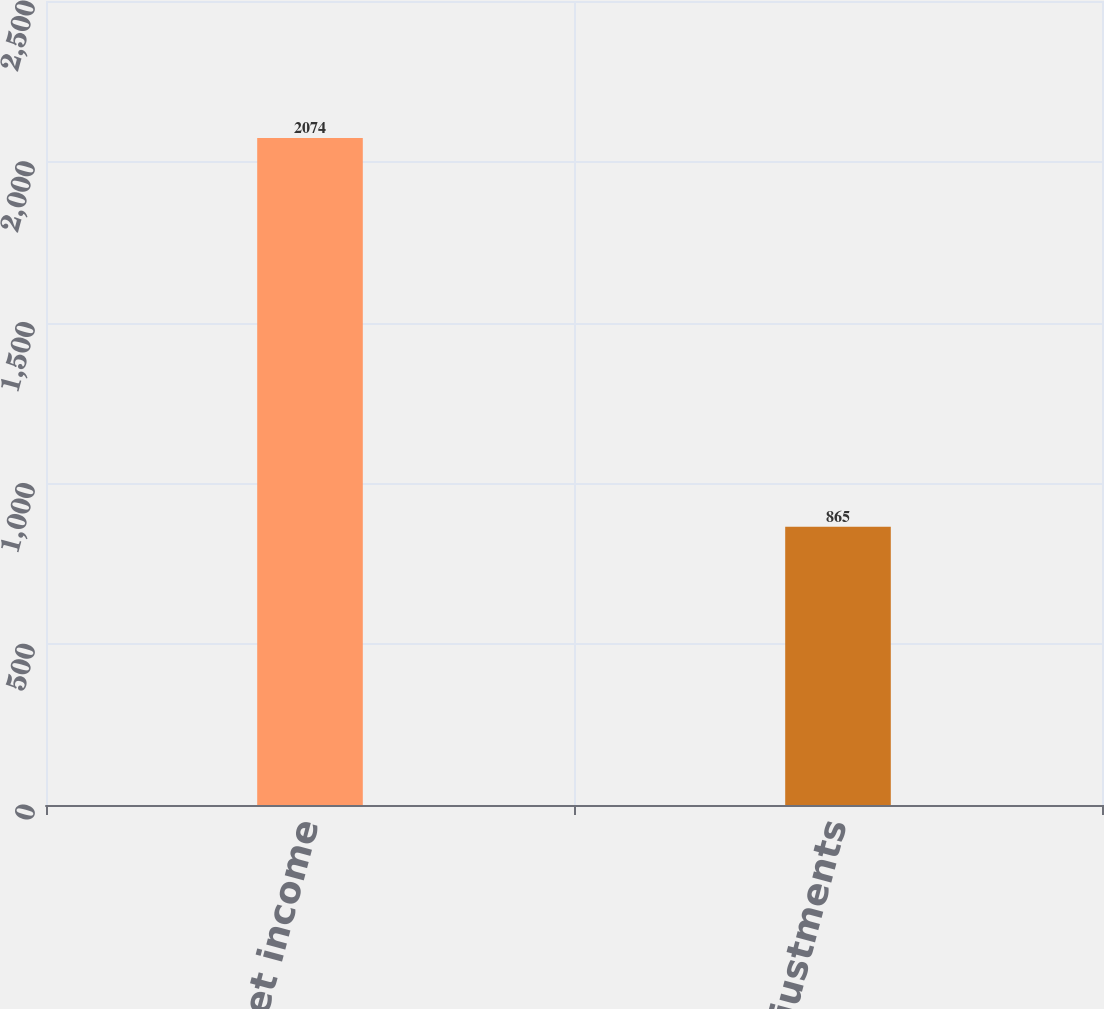Convert chart to OTSL. <chart><loc_0><loc_0><loc_500><loc_500><bar_chart><fcel>Net income<fcel>Adjustments<nl><fcel>2074<fcel>865<nl></chart> 